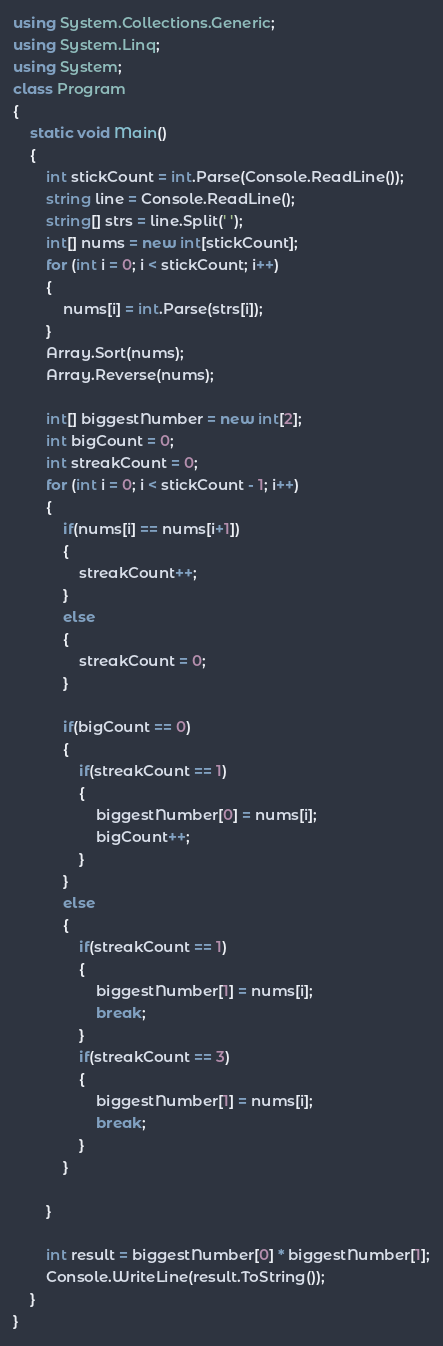<code> <loc_0><loc_0><loc_500><loc_500><_C#_>using System.Collections.Generic;
using System.Linq;
using System;
class Program
{
    static void Main()
    {
        int stickCount = int.Parse(Console.ReadLine());
        string line = Console.ReadLine();
        string[] strs = line.Split(' ');
        int[] nums = new int[stickCount];
        for (int i = 0; i < stickCount; i++)
        {
            nums[i] = int.Parse(strs[i]);
        }
        Array.Sort(nums);
        Array.Reverse(nums);

        int[] biggestNumber = new int[2];
        int bigCount = 0;
        int streakCount = 0;
        for (int i = 0; i < stickCount - 1; i++)
        {
            if(nums[i] == nums[i+1])
            {
                streakCount++;
            }
            else
            {
                streakCount = 0;
            }

            if(bigCount == 0)
            {
                if(streakCount == 1)
                {
                    biggestNumber[0] = nums[i];
                    bigCount++;
                }
            }
            else
            {
                if(streakCount == 1)
                {
                    biggestNumber[1] = nums[i];
                    break;
                }
                if(streakCount == 3)
                {
                    biggestNumber[1] = nums[i];
                    break;
                }
            }

        }

        int result = biggestNumber[0] * biggestNumber[1];
        Console.WriteLine(result.ToString());
    }
}</code> 